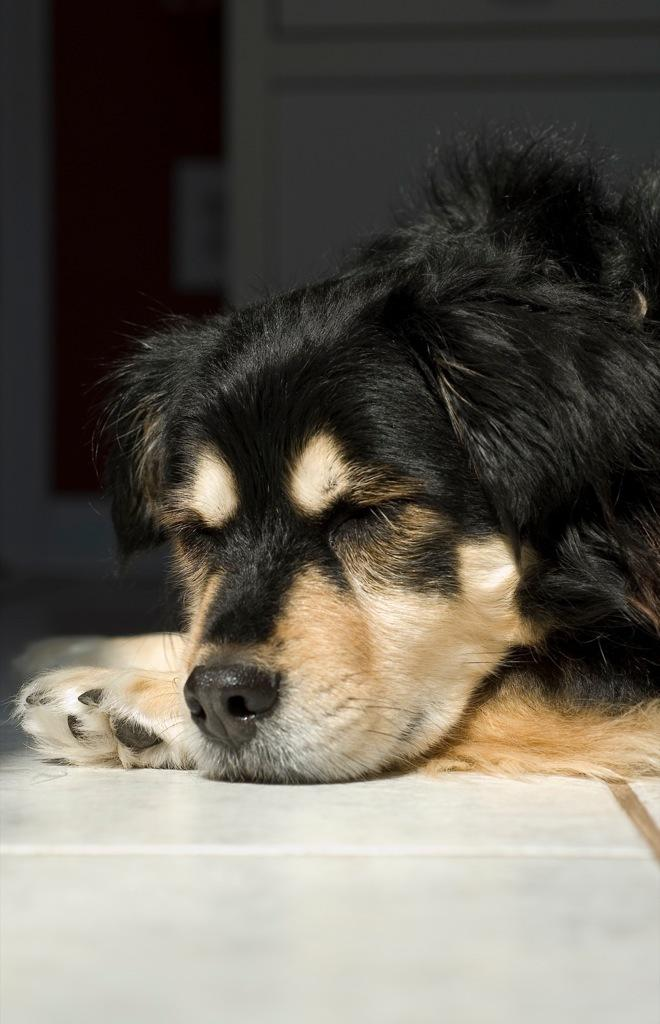What type of animal is present in the image? There is a dog in the image. What is the dog doing in the image? The dog is lying on the ground. What colors can be seen on the dog? The dog is black and brown in color. What structure is visible in the background of the image? There is a wall with a door in the image. What type of jewel is the dog wearing in the image? There is no jewel present on the dog in the image. 